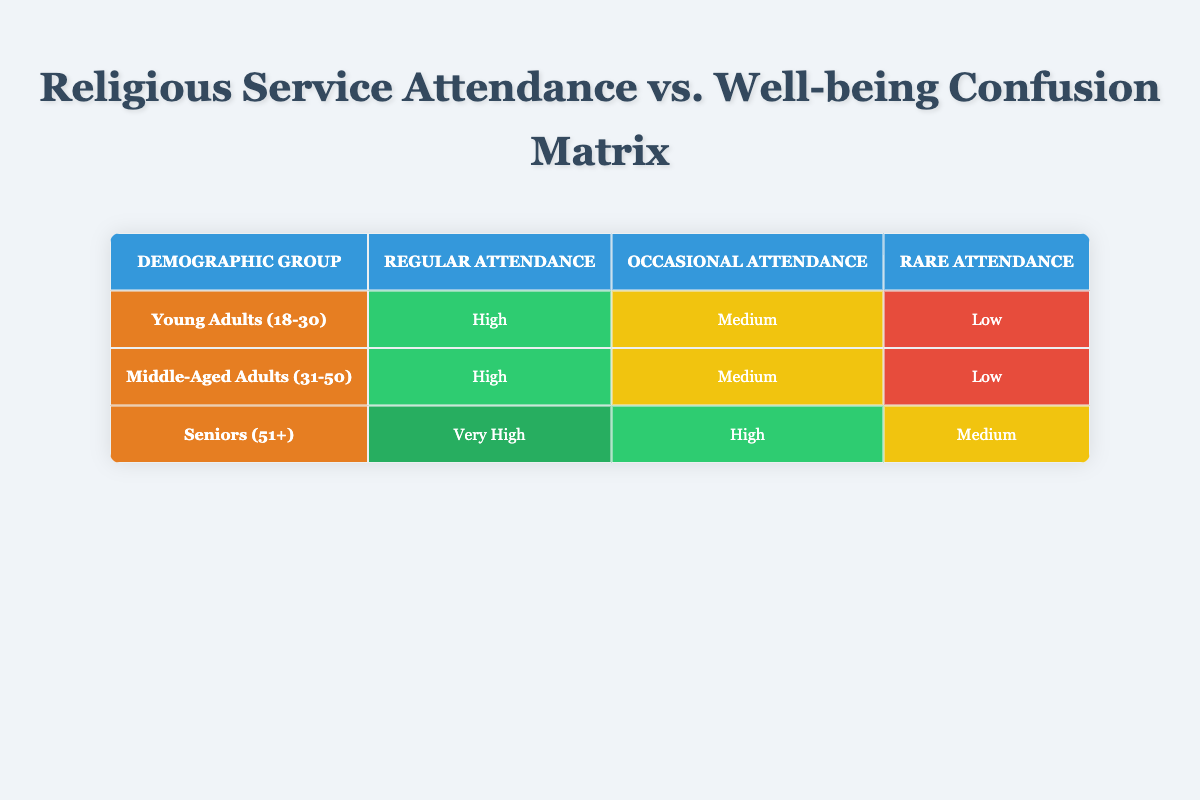What is the reported well-being level for Young Adults (18-30) with regular attendance? According to the table, the reported well-being level for Young Adults (18-30) with regular attendance at religious services is "High."
Answer: High What is the well-being level reported by Seniors (51+) who attend religious services occasionally? The table shows that Seniors (51+) who attend religious services occasionally report a well-being level of "High."
Answer: High Is there a demographic group that reports a well-being level of "Very High" for regular attendance? Yes, the table indicates that Seniors (51+) report a well-being level of "Very High" for regular attendance at religious services.
Answer: Yes Which demographic group has the highest reported well-being for regular attendance? The table indicates that Seniors (51+) have the highest reported well-being level of "Very High" for regular attendance compared to the other demographic groups.
Answer: Seniors (51+) What is the difference in reported well-being levels for Young Adults (18-30) between regular and rare attendance? For Young Adults (18-30), regular attendance has a reported well-being level of "High," while rare attendance is "Low." The difference is from "High" to "Low," which is a difference of two levels.
Answer: 2 levels How many groups report "Low" well-being levels for rare attendance? The table shows that both Young Adults (18-30) and Middle-Aged Adults (31-50) report "Low" well-being levels for rare attendance. Therefore, 2 groups report this level.
Answer: 2 groups What is the average well-being level reported for Middle-Aged Adults (31-50) across all attendance frequencies? The reported well-being levels for Middle-Aged Adults (31-50) are "High," "Medium," and "Low." To calculate the average: High (3) + Medium (2) + Low (1) = 6. There are 3 levels, so the average is 6/3 = 2 (average level = Medium).
Answer: Medium Is the overall pattern of well-being levels higher for regular attendance compared to occasional and rare attendance across all demographic groups? Yes, analyzing the well-being levels in the table shows that regular attendance has "High" or "Very High" levels, while occasional and rare attendance generally have "Medium" or "Low." This indicates that well-being levels are higher for regular attendance.
Answer: Yes 